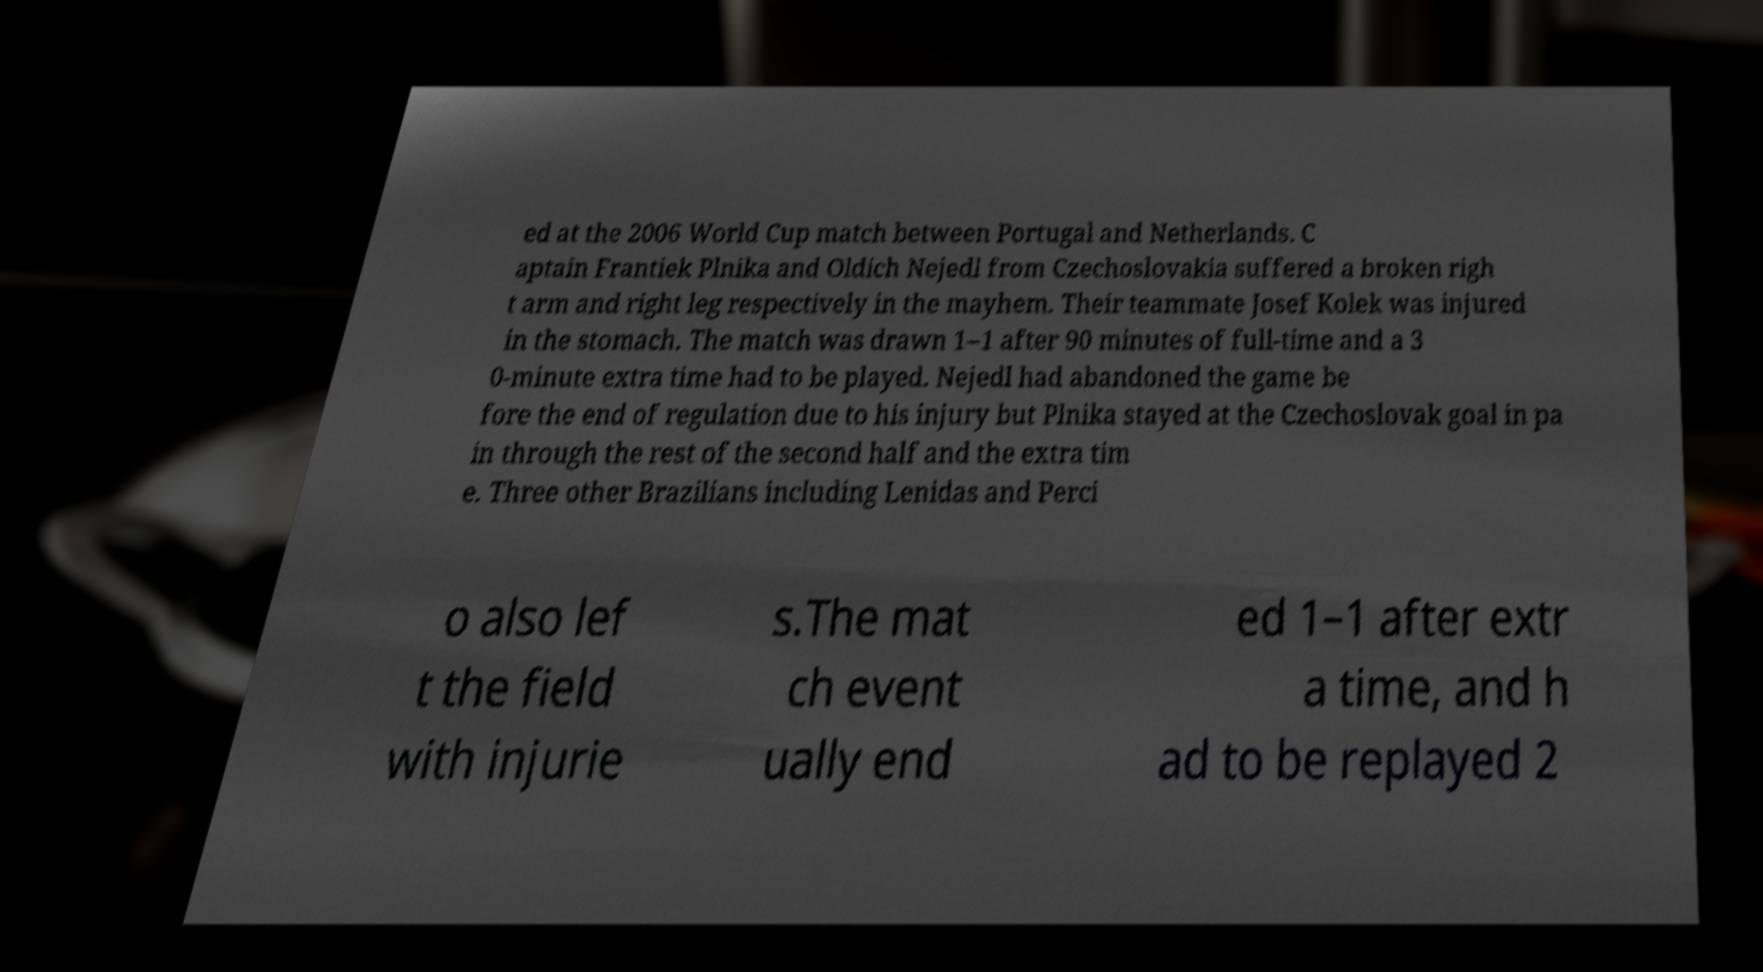Can you accurately transcribe the text from the provided image for me? ed at the 2006 World Cup match between Portugal and Netherlands. C aptain Frantiek Plnika and Oldich Nejedl from Czechoslovakia suffered a broken righ t arm and right leg respectively in the mayhem. Their teammate Josef Kolek was injured in the stomach. The match was drawn 1–1 after 90 minutes of full-time and a 3 0-minute extra time had to be played. Nejedl had abandoned the game be fore the end of regulation due to his injury but Plnika stayed at the Czechoslovak goal in pa in through the rest of the second half and the extra tim e. Three other Brazilians including Lenidas and Perci o also lef t the field with injurie s.The mat ch event ually end ed 1–1 after extr a time, and h ad to be replayed 2 